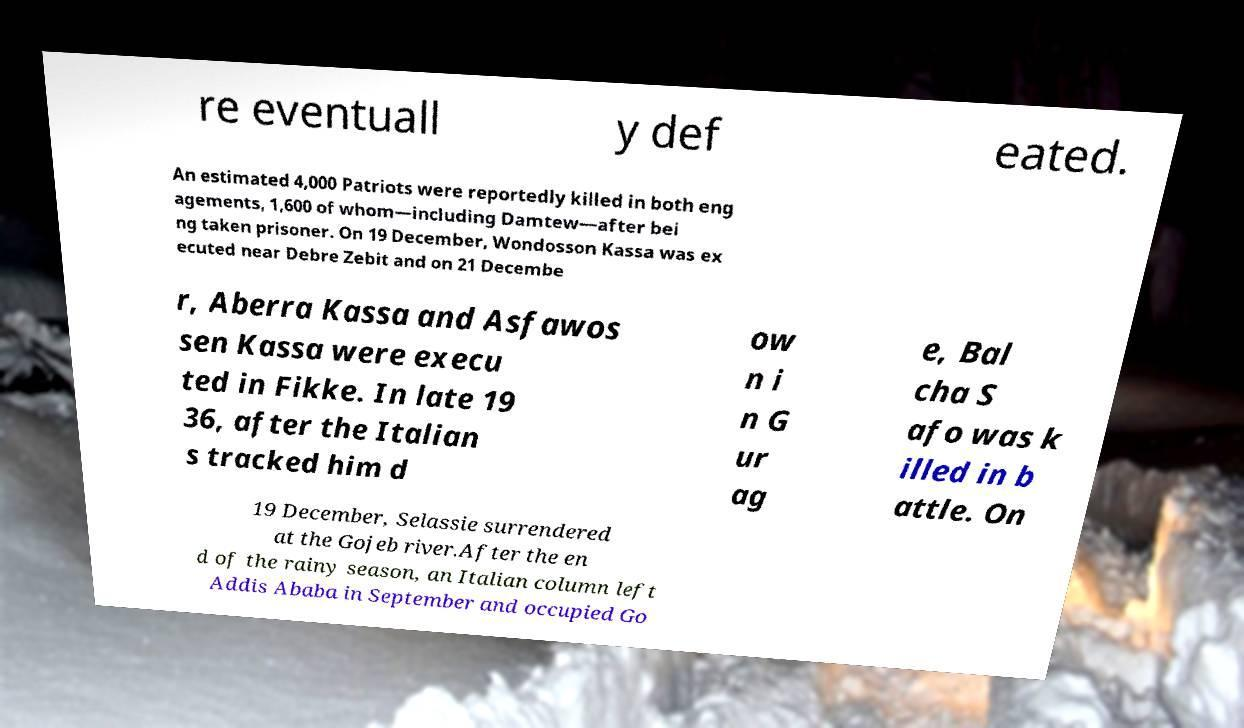Can you read and provide the text displayed in the image?This photo seems to have some interesting text. Can you extract and type it out for me? re eventuall y def eated. An estimated 4,000 Patriots were reportedly killed in both eng agements, 1,600 of whom—including Damtew—after bei ng taken prisoner. On 19 December, Wondosson Kassa was ex ecuted near Debre Zebit and on 21 Decembe r, Aberra Kassa and Asfawos sen Kassa were execu ted in Fikke. In late 19 36, after the Italian s tracked him d ow n i n G ur ag e, Bal cha S afo was k illed in b attle. On 19 December, Selassie surrendered at the Gojeb river.After the en d of the rainy season, an Italian column left Addis Ababa in September and occupied Go 